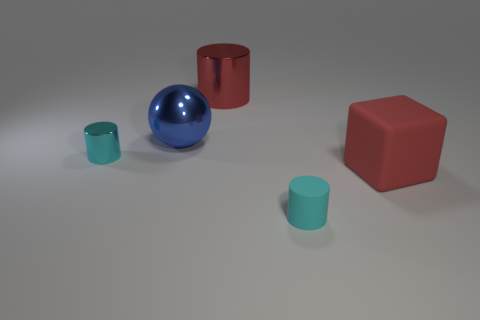Does the big thing that is to the left of the large red metal thing have the same material as the red block?
Provide a succinct answer. No. There is a tiny matte object; is it the same color as the small object that is behind the red rubber thing?
Your answer should be very brief. Yes. Are there any large metal balls on the left side of the cyan rubber cylinder?
Offer a very short reply. Yes. Is the size of the cylinder that is in front of the big matte block the same as the shiny cylinder that is in front of the red cylinder?
Your response must be concise. Yes. Are there any yellow rubber things of the same size as the red metal thing?
Your answer should be compact. No. Is the shape of the tiny cyan object that is right of the big red metallic object the same as  the tiny cyan shiny thing?
Offer a terse response. Yes. What material is the small cyan object in front of the red block?
Ensure brevity in your answer.  Rubber. There is a rubber thing that is behind the tiny cyan matte cylinder that is in front of the big blue sphere; what shape is it?
Provide a succinct answer. Cube. Is the shape of the red metallic object the same as the big object that is in front of the blue object?
Keep it short and to the point. No. There is a object to the right of the tiny matte cylinder; how many objects are to the left of it?
Provide a succinct answer. 4. 